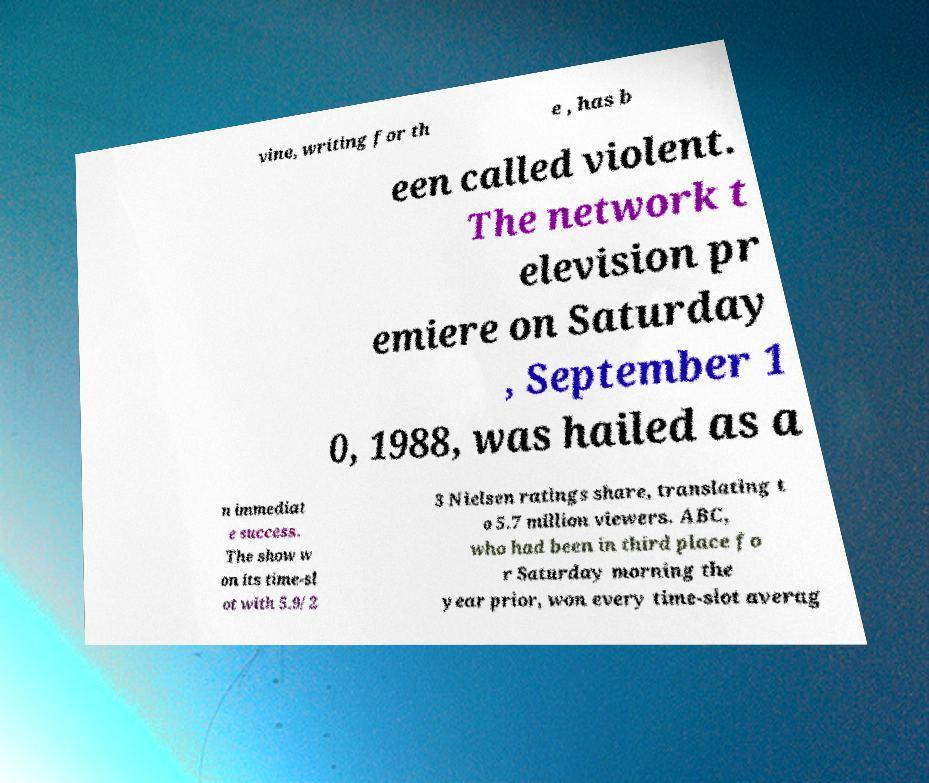Please read and relay the text visible in this image. What does it say? vine, writing for th e , has b een called violent. The network t elevision pr emiere on Saturday , September 1 0, 1988, was hailed as a n immediat e success. The show w on its time-sl ot with 5.9/2 3 Nielsen ratings share, translating t o 5.7 million viewers. ABC, who had been in third place fo r Saturday morning the year prior, won every time-slot averag 